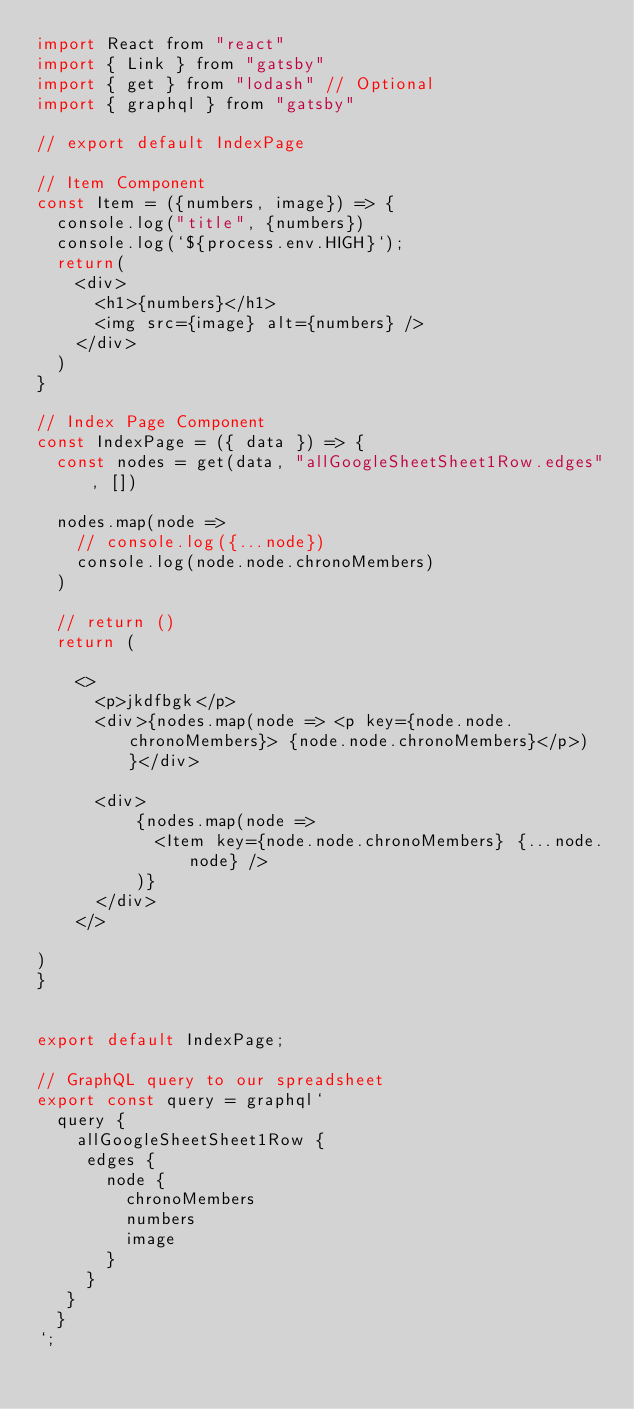Convert code to text. <code><loc_0><loc_0><loc_500><loc_500><_JavaScript_>import React from "react"
import { Link } from "gatsby"
import { get } from "lodash" // Optional
import { graphql } from "gatsby"

// export default IndexPage

// Item Component
const Item = ({numbers, image}) => {
  console.log("title", {numbers})
  console.log(`${process.env.HIGH}`);
  return(
    <div>
      <h1>{numbers}</h1>
      <img src={image} alt={numbers} />
    </div>
  )
}

// Index Page Component
const IndexPage = ({ data }) => {
  const nodes = get(data, "allGoogleSheetSheet1Row.edges", [])

  nodes.map(node =>
    // console.log({...node})
    console.log(node.node.chronoMembers)
  )

  // return ()
  return (

    <>
      <p>jkdfbgk</p>
      <div>{nodes.map(node => <p key={node.node.chronoMembers}> {node.node.chronoMembers}</p>)}</div>

      <div>
          {nodes.map(node =>
            <Item key={node.node.chronoMembers} {...node.node} />
          )}
      </div>
    </>

)
}


export default IndexPage;

// GraphQL query to our spreadsheet
export const query = graphql`
  query {
    allGoogleSheetSheet1Row {
     edges {
       node {
         chronoMembers
         numbers
         image
       }
     }
   }
  }
`;
</code> 